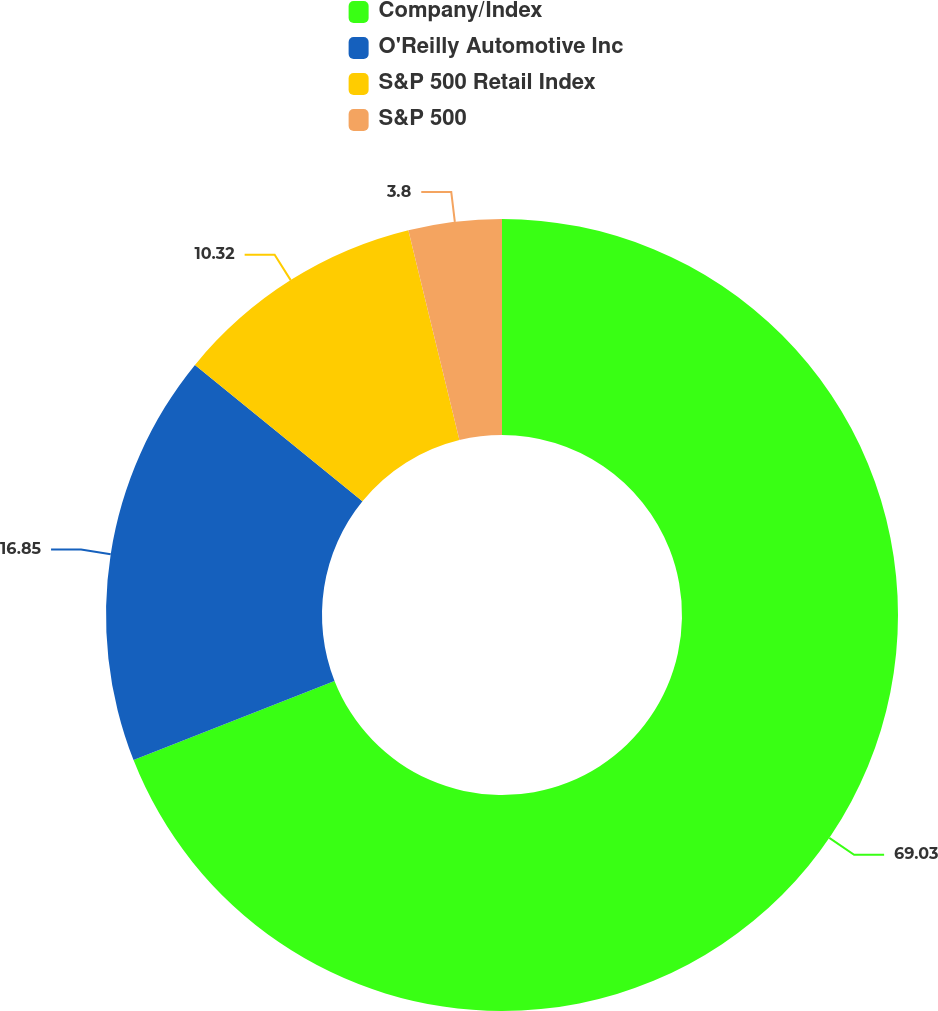Convert chart to OTSL. <chart><loc_0><loc_0><loc_500><loc_500><pie_chart><fcel>Company/Index<fcel>O'Reilly Automotive Inc<fcel>S&P 500 Retail Index<fcel>S&P 500<nl><fcel>69.03%<fcel>16.85%<fcel>10.32%<fcel>3.8%<nl></chart> 